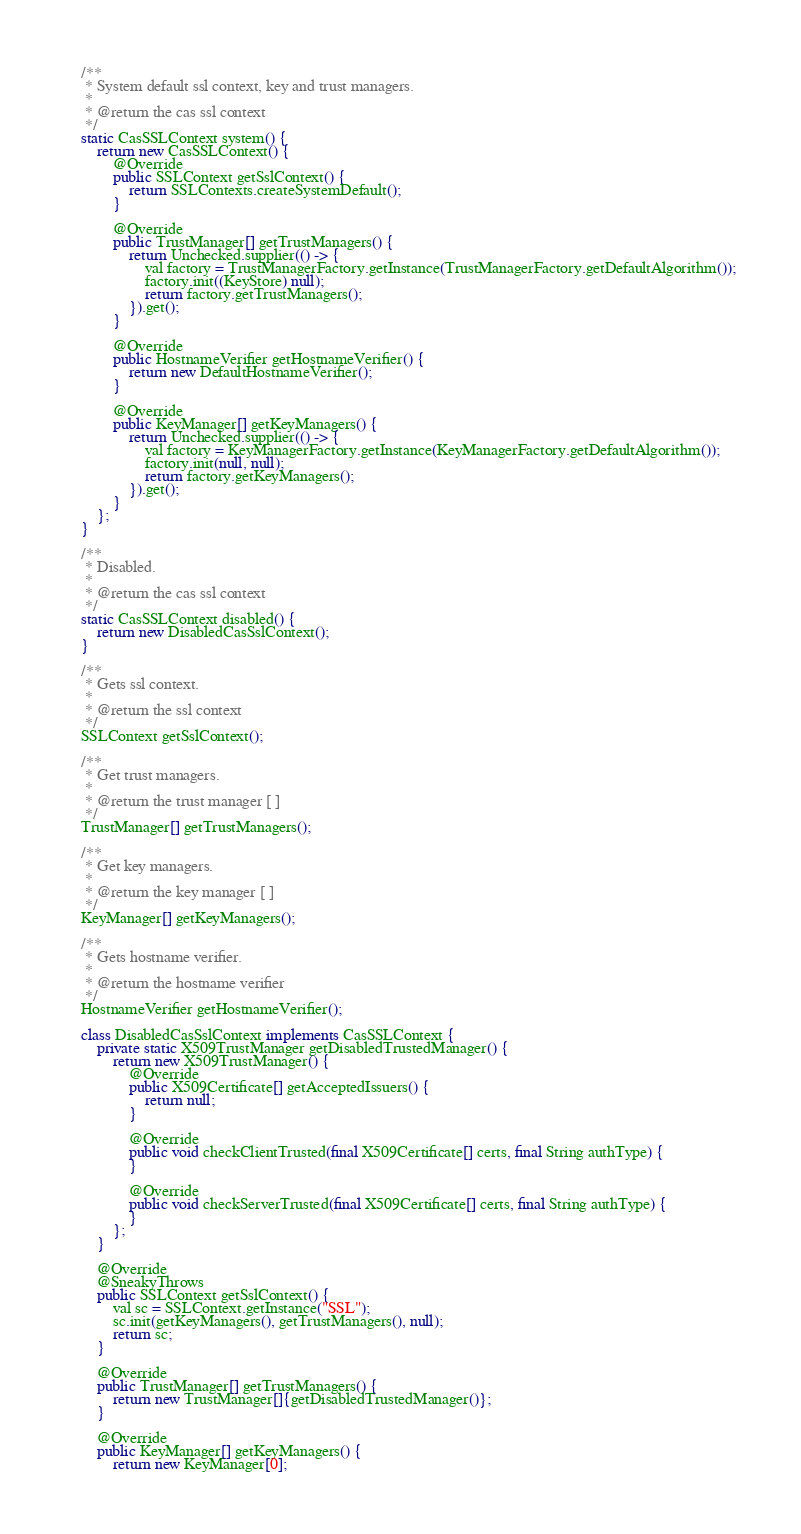Convert code to text. <code><loc_0><loc_0><loc_500><loc_500><_Java_>    /**
     * System default ssl context, key and trust managers.
     *
     * @return the cas ssl context
     */
    static CasSSLContext system() {
        return new CasSSLContext() {
            @Override
            public SSLContext getSslContext() {
                return SSLContexts.createSystemDefault();
            }

            @Override
            public TrustManager[] getTrustManagers() {
                return Unchecked.supplier(() -> {
                    val factory = TrustManagerFactory.getInstance(TrustManagerFactory.getDefaultAlgorithm());
                    factory.init((KeyStore) null);
                    return factory.getTrustManagers();
                }).get();
            }

            @Override
            public HostnameVerifier getHostnameVerifier() {
                return new DefaultHostnameVerifier();
            }

            @Override
            public KeyManager[] getKeyManagers() {
                return Unchecked.supplier(() -> {
                    val factory = KeyManagerFactory.getInstance(KeyManagerFactory.getDefaultAlgorithm());
                    factory.init(null, null);
                    return factory.getKeyManagers();
                }).get();
            }
        };
    }

    /**
     * Disabled.
     *
     * @return the cas ssl context
     */
    static CasSSLContext disabled() {
        return new DisabledCasSslContext();
    }

    /**
     * Gets ssl context.
     *
     * @return the ssl context
     */
    SSLContext getSslContext();

    /**
     * Get trust managers.
     *
     * @return the trust manager [ ]
     */
    TrustManager[] getTrustManagers();

    /**
     * Get key managers.
     *
     * @return the key manager [ ]
     */
    KeyManager[] getKeyManagers();

    /**
     * Gets hostname verifier.
     *
     * @return the hostname verifier
     */
    HostnameVerifier getHostnameVerifier();

    class DisabledCasSslContext implements CasSSLContext {
        private static X509TrustManager getDisabledTrustedManager() {
            return new X509TrustManager() {
                @Override
                public X509Certificate[] getAcceptedIssuers() {
                    return null;
                }

                @Override
                public void checkClientTrusted(final X509Certificate[] certs, final String authType) {
                }

                @Override
                public void checkServerTrusted(final X509Certificate[] certs, final String authType) {
                }
            };
        }

        @Override
        @SneakyThrows
        public SSLContext getSslContext() {
            val sc = SSLContext.getInstance("SSL");
            sc.init(getKeyManagers(), getTrustManagers(), null);
            return sc;
        }

        @Override
        public TrustManager[] getTrustManagers() {
            return new TrustManager[]{getDisabledTrustedManager()};
        }

        @Override
        public KeyManager[] getKeyManagers() {
            return new KeyManager[0];</code> 